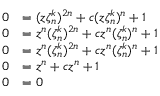Convert formula to latex. <formula><loc_0><loc_0><loc_500><loc_500>\begin{array} { r l } { 0 } & { = ( z \zeta _ { n } ^ { k } ) ^ { 2 n } + c ( z \zeta _ { n } ^ { k } ) ^ { n } + 1 } \\ { 0 } & { = z ^ { n } ( \zeta _ { n } ^ { k } ) ^ { 2 n } + c z ^ { n } ( \zeta _ { n } ^ { k } ) ^ { n } + 1 } \\ { 0 } & { = z ^ { n } ( \zeta _ { n } ^ { k } ) ^ { 2 n } + c z ^ { n } ( \zeta _ { n } ^ { k } ) ^ { n } + 1 } \\ { 0 } & { = z ^ { n } + c z ^ { n } + 1 } \\ { 0 } & { = 0 } \end{array}</formula> 